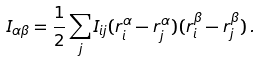Convert formula to latex. <formula><loc_0><loc_0><loc_500><loc_500>I _ { \alpha \beta } = \frac { 1 } { 2 } \sum _ { j } I _ { i j } ( r _ { i } ^ { \alpha } - r _ { j } ^ { \alpha } ) ( r _ { i } ^ { \beta } - r _ { j } ^ { \beta } ) \, .</formula> 